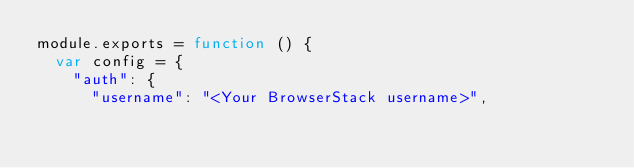Convert code to text. <code><loc_0><loc_0><loc_500><loc_500><_JavaScript_>module.exports = function () {
  var config = {
    "auth": {
      "username": "<Your BrowserStack username>",</code> 